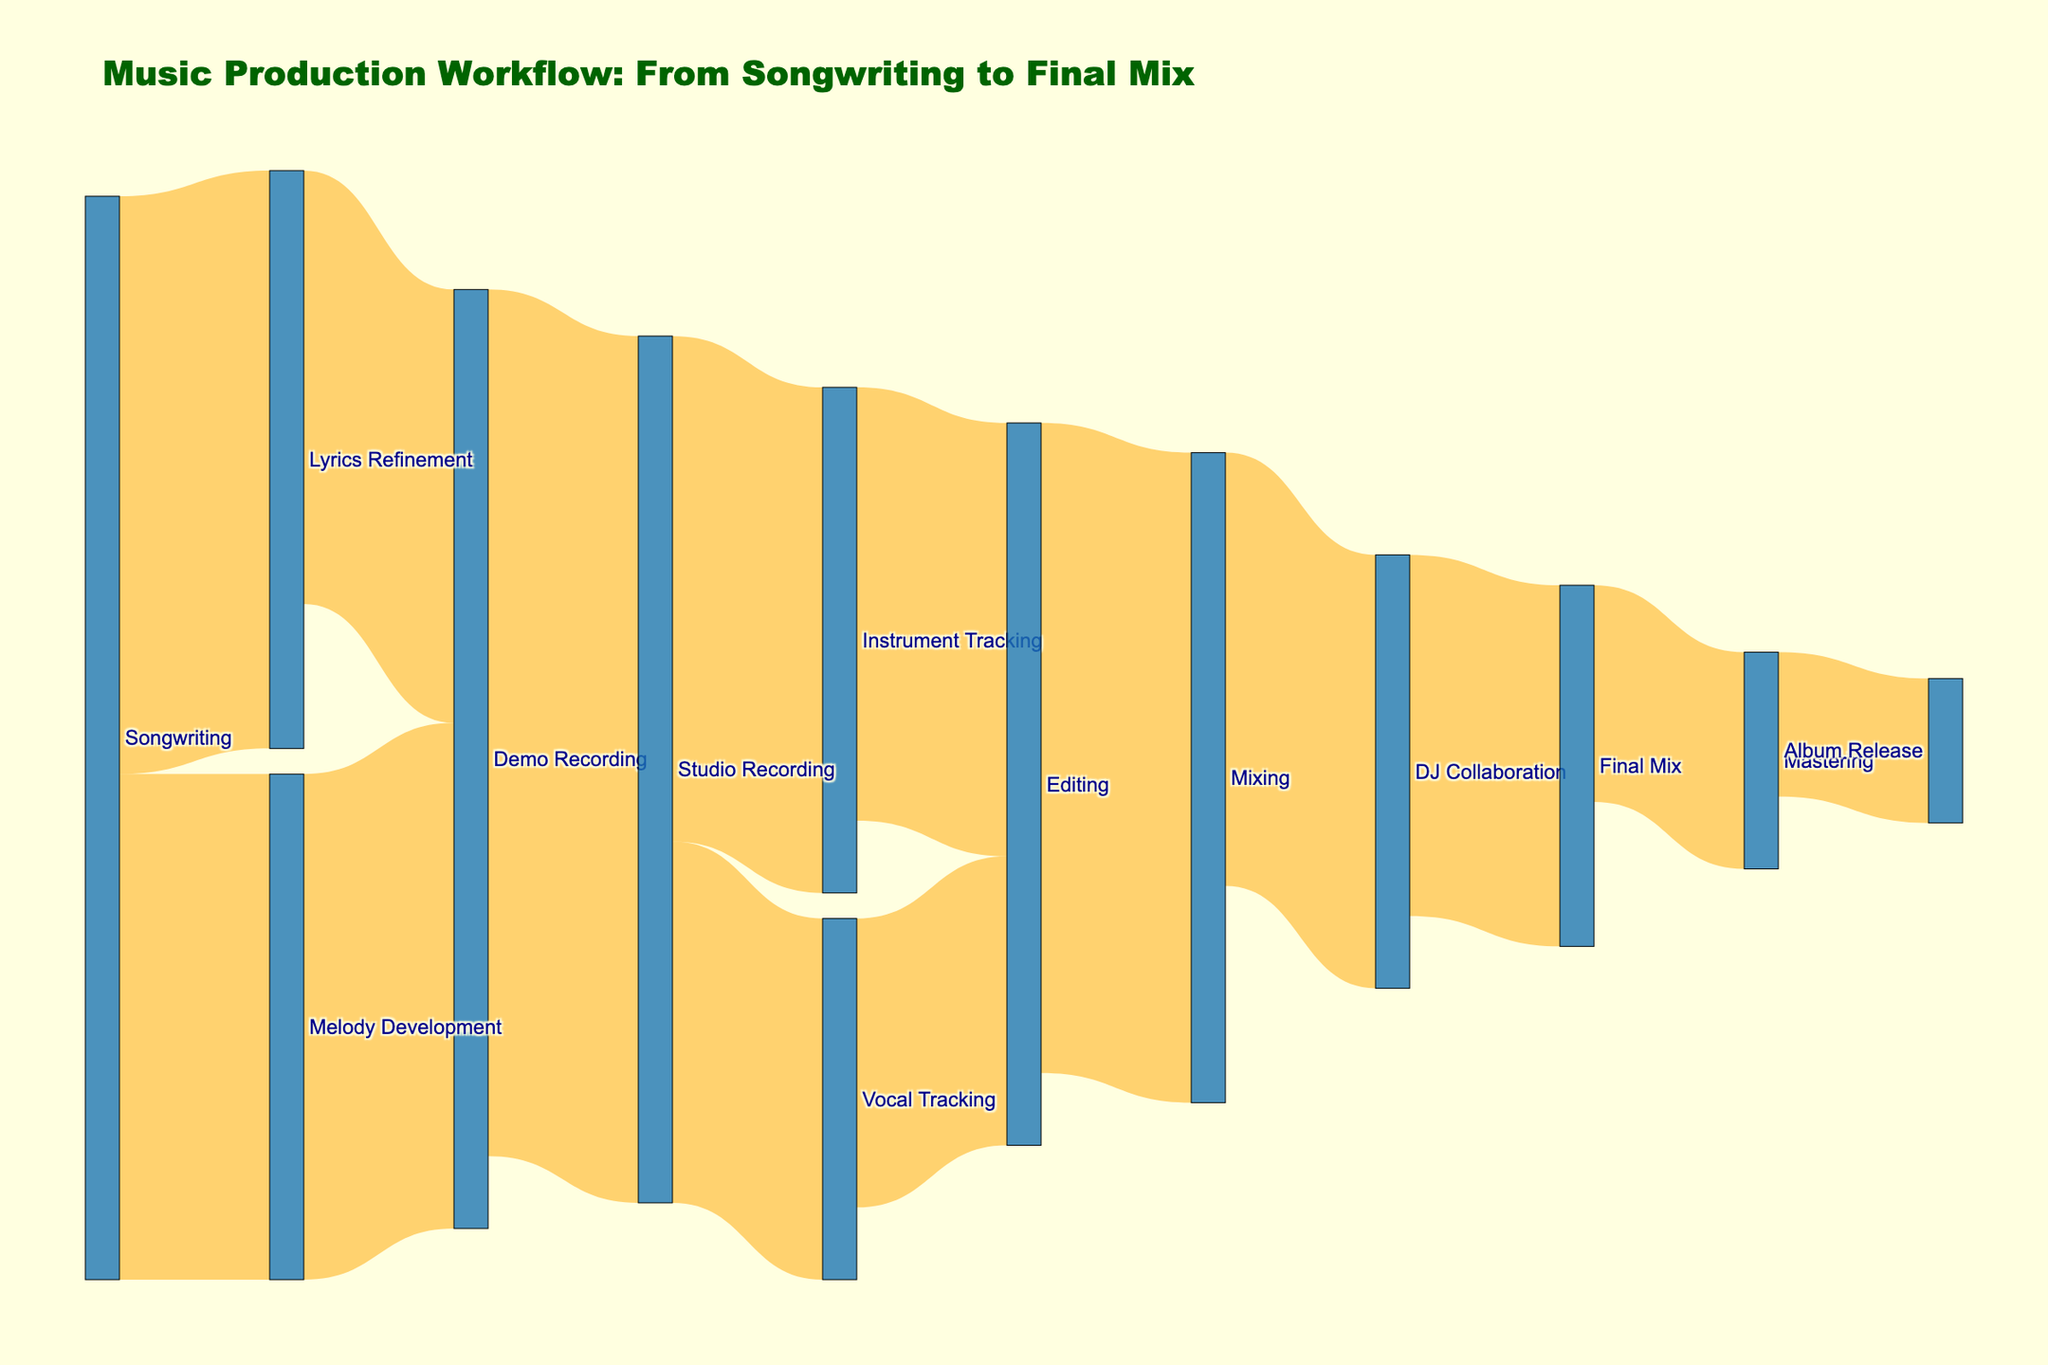What's the title of the figure? The figure contains a title located at the top. By visually inspecting the figure, you can see the text clearly displayed as the title.
Answer: Music Production Workflow: From Songwriting to Final Mix How much time is spent on Melody Development? In the figure, the link from Songwriting to Melody Development shows the value associated with it.
Answer: 35 What comes after Demo Recording in the workflow? Follow the link from Demo Recording to the subsequent stages. The links from Demo Recording are directed to Studio Recording.
Answer: Studio Recording Compare the time spent on Vocal Tracking and Instrument Tracking. Which stage takes longer? Check the links connecting Studio Recording to Vocal Tracking and Instrument Tracking. Compare the values.
Answer: Instrument Tracking What is the final stage before the album release? Look at the stage leading directly to Album Release. The final incoming link to Album Release shows the stage that precedes it.
Answer: Mastering How much total time is spent from Songwriting to Demo Recording? Add the time spent on Songwriting to Lyrics Refinement and Melody Development, then add the time spent from Lyrics Refinement to Demo Recording and Melody Development to Demo Recording. 40 (Lyrics Refinement) + 35 (Melody Development) + 30 (Demo Recording via Lyrics Refinement) + 35 (Demo Recording via Melody Development)
Answer: 140 What is the total time spent in the Mixing stage and all subsequent stages until Album Release? Sum the time spent on Mixing, DJ Collaboration, Final Mix, Mastering, and Album Release. 45 (Mixing) + 30 (DJ Collaboration) + 25 (Final Mix) + 15 (Mastering) + 10 (Album Release)
Answer: 125 Between the stages of Songwriting to Final Mix, identify the stage with the highest time value. Identify the stage's link with the highest value in the entire figure.
Answer: Studio Recording How many stages lead directly to Editing? Count the number of direct links to Editing in the Sankey Diagram.
Answer: 2 What is the combined time spent in the Studio Recording stage? Sum the time for the paths from Studio Recording to Vocal Tracking and Instrument Tracking. 25 (Vocal Tracking) + 35 (Instrument Tracking)
Answer: 60 